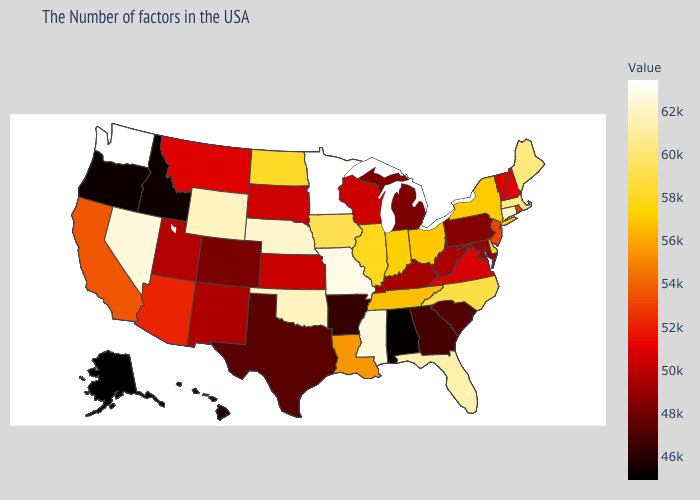Which states hav the highest value in the South?
Quick response, please. Mississippi. Which states have the lowest value in the USA?
Write a very short answer. Alaska. Among the states that border Ohio , which have the highest value?
Concise answer only. Indiana. Does Washington have the highest value in the USA?
Short answer required. Yes. Does Minnesota have the highest value in the MidWest?
Be succinct. Yes. 